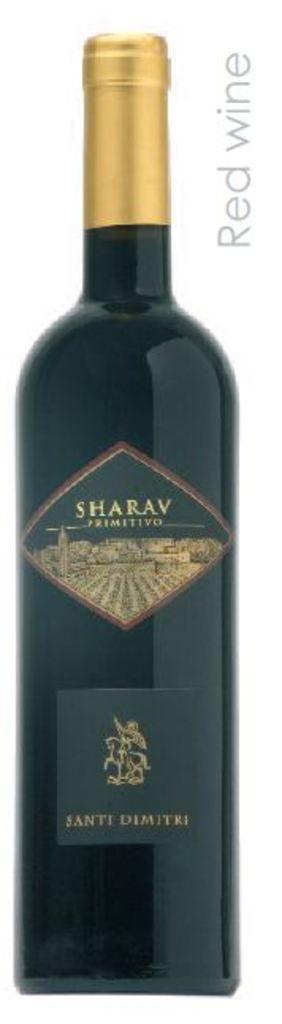In one or two sentences, can you explain what this image depicts? In the center of the image we can see a wine bottle. At the top right corner some text is there. 